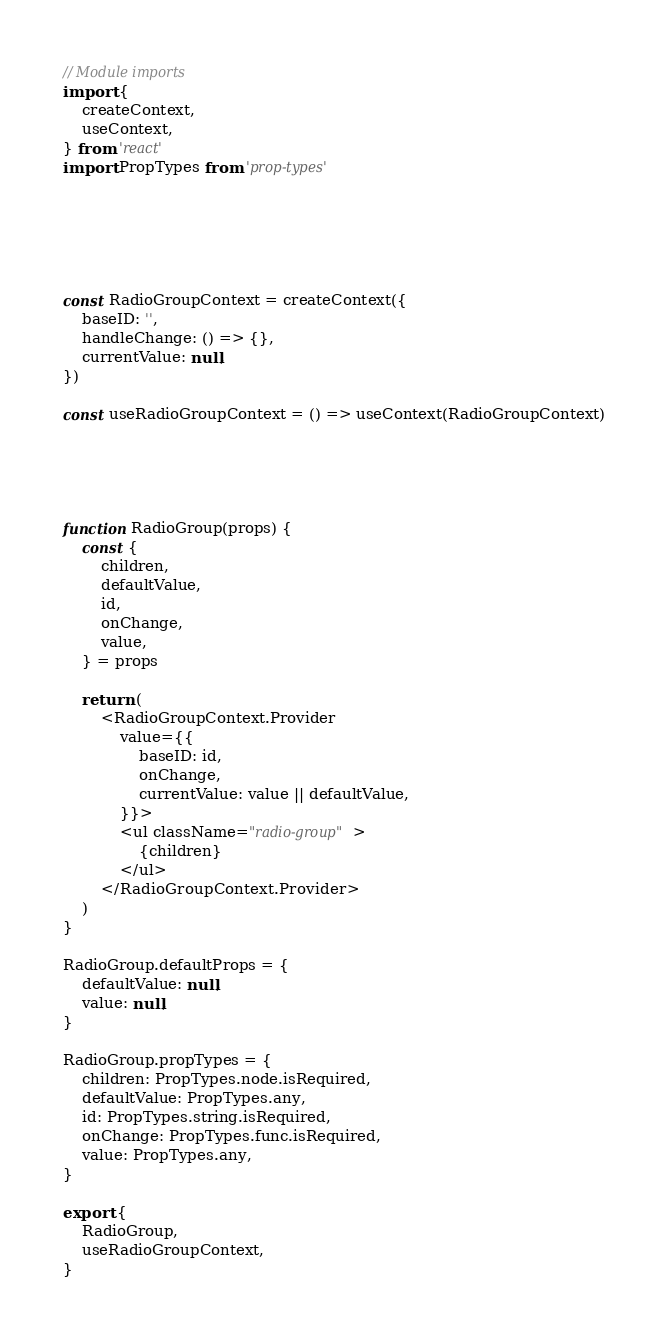Convert code to text. <code><loc_0><loc_0><loc_500><loc_500><_JavaScript_>// Module imports
import {
	createContext,
	useContext,
} from 'react'
import PropTypes from 'prop-types'






const RadioGroupContext = createContext({
	baseID: '',
	handleChange: () => {},
	currentValue: null,
})

const useRadioGroupContext = () => useContext(RadioGroupContext)





function RadioGroup(props) {
	const {
		children,
		defaultValue,
		id,
		onChange,
		value,
	} = props

	return (
		<RadioGroupContext.Provider
			value={{
				baseID: id,
				onChange,
				currentValue: value || defaultValue,
			}}>
			<ul className="radio-group">
				{children}
			</ul>
		</RadioGroupContext.Provider>
	)
}

RadioGroup.defaultProps = {
	defaultValue: null,
	value: null,
}

RadioGroup.propTypes = {
	children: PropTypes.node.isRequired,
	defaultValue: PropTypes.any,
	id: PropTypes.string.isRequired,
	onChange: PropTypes.func.isRequired,
	value: PropTypes.any,
}

export {
	RadioGroup,
	useRadioGroupContext,
}
</code> 